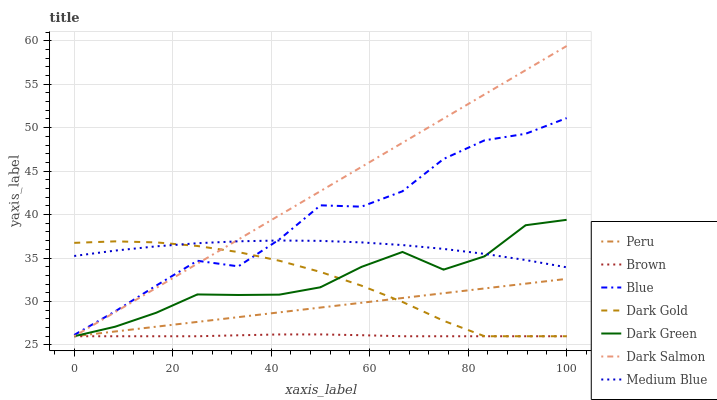Does Brown have the minimum area under the curve?
Answer yes or no. Yes. Does Dark Salmon have the maximum area under the curve?
Answer yes or no. Yes. Does Dark Gold have the minimum area under the curve?
Answer yes or no. No. Does Dark Gold have the maximum area under the curve?
Answer yes or no. No. Is Peru the smoothest?
Answer yes or no. Yes. Is Blue the roughest?
Answer yes or no. Yes. Is Brown the smoothest?
Answer yes or no. No. Is Brown the roughest?
Answer yes or no. No. Does Brown have the lowest value?
Answer yes or no. Yes. Does Medium Blue have the lowest value?
Answer yes or no. No. Does Dark Salmon have the highest value?
Answer yes or no. Yes. Does Dark Gold have the highest value?
Answer yes or no. No. Is Brown less than Blue?
Answer yes or no. Yes. Is Blue greater than Brown?
Answer yes or no. Yes. Does Peru intersect Brown?
Answer yes or no. Yes. Is Peru less than Brown?
Answer yes or no. No. Is Peru greater than Brown?
Answer yes or no. No. Does Brown intersect Blue?
Answer yes or no. No. 